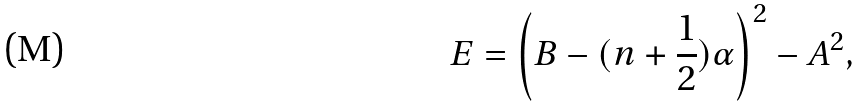Convert formula to latex. <formula><loc_0><loc_0><loc_500><loc_500>E = \left ( B - ( n + \frac { 1 } { 2 } ) \alpha \right ) ^ { 2 } - A ^ { 2 } ,</formula> 